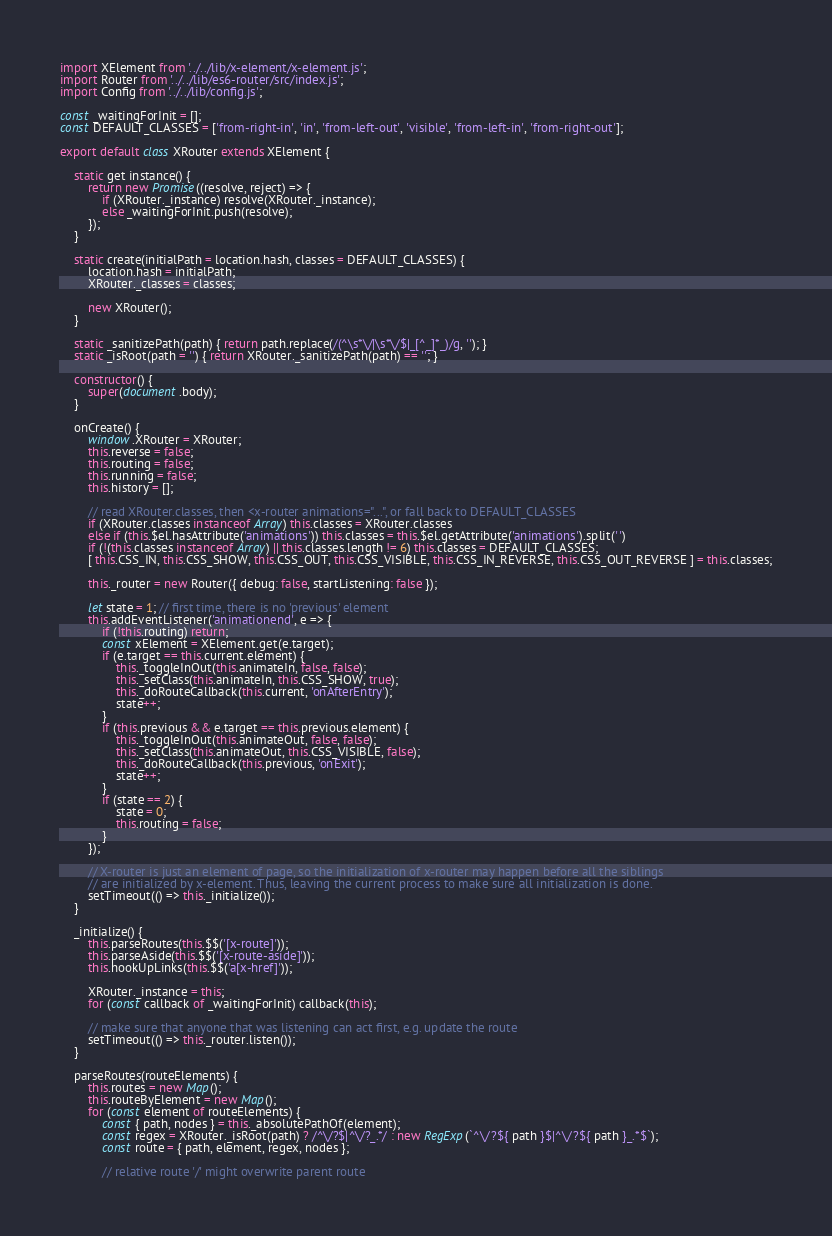Convert code to text. <code><loc_0><loc_0><loc_500><loc_500><_JavaScript_>import XElement from '../../lib/x-element/x-element.js';
import Router from '../../lib/es6-router/src/index.js';
import Config from '../../lib/config.js';

const _waitingForInit = [];
const DEFAULT_CLASSES = ['from-right-in', 'in', 'from-left-out', 'visible', 'from-left-in', 'from-right-out'];

export default class XRouter extends XElement {

    static get instance() {
        return new Promise((resolve, reject) => {
            if (XRouter._instance) resolve(XRouter._instance);
            else _waitingForInit.push(resolve);
        });
    }

    static create(initialPath = location.hash, classes = DEFAULT_CLASSES) {
        location.hash = initialPath;
        XRouter._classes = classes;

        new XRouter();
    }

    static _sanitizePath(path) { return path.replace(/(^\s*\/|\s*\/$|_[^_]*_)/g, ''); }
    static _isRoot(path = '') { return XRouter._sanitizePath(path) == ''; }

    constructor() {
        super(document.body);
    }

    onCreate() {
        window.XRouter = XRouter;
        this.reverse = false;
        this.routing = false;
        this.running = false;
        this.history = [];

        // read XRouter.classes, then <x-router animations="...", or fall back to DEFAULT_CLASSES
        if (XRouter.classes instanceof Array) this.classes = XRouter.classes
        else if (this.$el.hasAttribute('animations')) this.classes = this.$el.getAttribute('animations').split(' ')
        if (!(this.classes instanceof Array) || this.classes.length != 6) this.classes = DEFAULT_CLASSES;
        [ this.CSS_IN, this.CSS_SHOW, this.CSS_OUT, this.CSS_VISIBLE, this.CSS_IN_REVERSE, this.CSS_OUT_REVERSE ] = this.classes;

        this._router = new Router({ debug: false, startListening: false });

        let state = 1; // first time, there is no 'previous' element
        this.addEventListener('animationend', e => {
            if (!this.routing) return;
            const xElement = XElement.get(e.target);
            if (e.target == this.current.element) {
                this._toggleInOut(this.animateIn, false, false);
                this._setClass(this.animateIn, this.CSS_SHOW, true);
                this._doRouteCallback(this.current, 'onAfterEntry');
                state++;
            }
            if (this.previous && e.target == this.previous.element) {
                this._toggleInOut(this.animateOut, false, false);
                this._setClass(this.animateOut, this.CSS_VISIBLE, false);
                this._doRouteCallback(this.previous, 'onExit');
                state++;
            }
            if (state == 2) {
                state = 0;
                this.routing = false;
            }
        });

        // X-router is just an element of page, so the initialization of x-router may happen before all the siblings
        // are initialized by x-element. Thus, leaving the current process to make sure all initialization is done.
        setTimeout(() => this._initialize());
    }

    _initialize() {
        this.parseRoutes(this.$$('[x-route]'));
        this.parseAside(this.$$('[x-route-aside]'));
        this.hookUpLinks(this.$$('a[x-href]'));

        XRouter._instance = this;
        for (const callback of _waitingForInit) callback(this);

        // make sure that anyone that was listening can act first, e.g. update the route
        setTimeout(() => this._router.listen());
    }

    parseRoutes(routeElements) {
        this.routes = new Map();
        this.routeByElement = new Map();
        for (const element of routeElements) {
            const { path, nodes } = this._absolutePathOf(element);
            const regex = XRouter._isRoot(path) ? /^\/?$|^\/?_.*/ : new RegExp(`^\/?${ path }$|^\/?${ path }_.*$`);
            const route = { path, element, regex, nodes };

            // relative route '/' might overwrite parent route</code> 